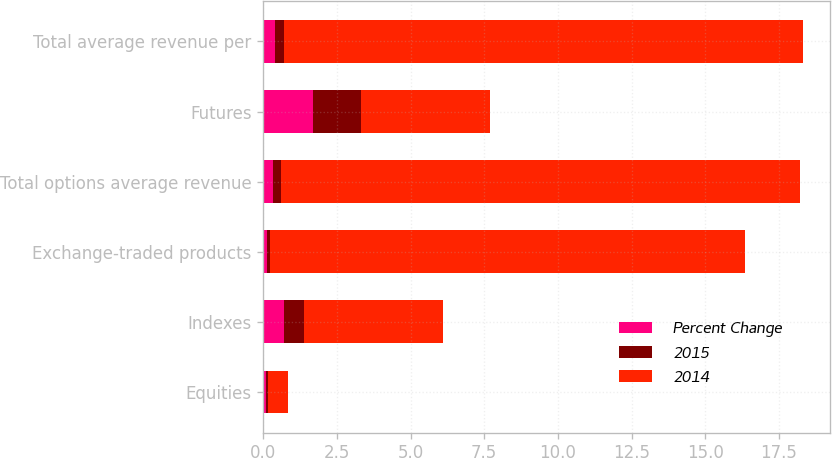Convert chart to OTSL. <chart><loc_0><loc_0><loc_500><loc_500><stacked_bar_chart><ecel><fcel>Equities<fcel>Indexes<fcel>Exchange-traded products<fcel>Total options average revenue<fcel>Futures<fcel>Total average revenue per<nl><fcel>Percent Change<fcel>0.09<fcel>0.71<fcel>0.13<fcel>0.33<fcel>1.69<fcel>0.39<nl><fcel>2015<fcel>0.08<fcel>0.68<fcel>0.11<fcel>0.28<fcel>1.62<fcel>0.33<nl><fcel>2014<fcel>0.68<fcel>4.7<fcel>16.1<fcel>17.6<fcel>4.4<fcel>17.6<nl></chart> 